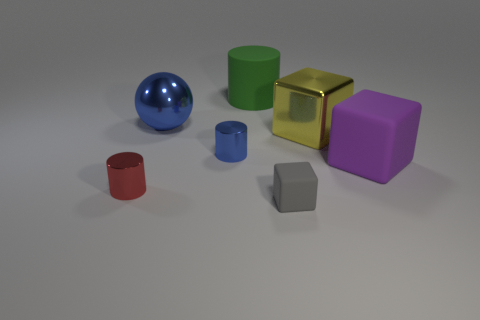What size is the blue shiny sphere?
Give a very brief answer. Large. What size is the yellow metal thing that is the same shape as the purple thing?
Provide a succinct answer. Large. Are there any other things that are the same shape as the big blue metal thing?
Your response must be concise. No. What color is the small matte object that is the same shape as the big yellow metallic thing?
Offer a terse response. Gray. There is a big metal thing on the left side of the gray matte thing; is its color the same as the small metal thing that is behind the big purple thing?
Your answer should be compact. Yes. Is the number of big objects that are right of the large blue shiny sphere greater than the number of metal cubes?
Provide a succinct answer. Yes. How many other things are the same size as the metal cube?
Your answer should be compact. 3. What number of big rubber objects are on the left side of the gray object and in front of the sphere?
Keep it short and to the point. 0. Are the big blue thing on the left side of the large yellow cube and the gray thing made of the same material?
Provide a succinct answer. No. What shape is the metal thing that is behind the big shiny thing right of the object that is behind the large blue metallic ball?
Your answer should be compact. Sphere. 